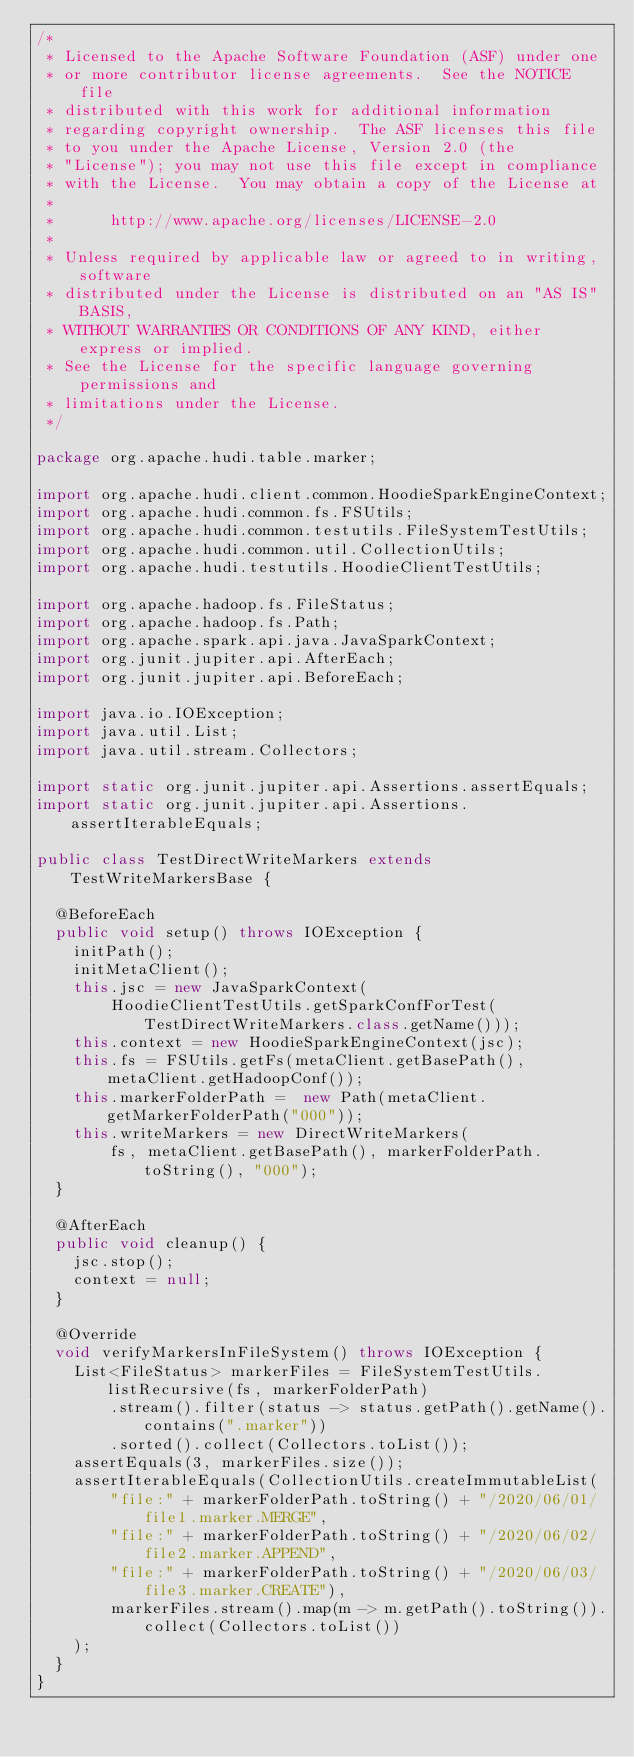<code> <loc_0><loc_0><loc_500><loc_500><_Java_>/*
 * Licensed to the Apache Software Foundation (ASF) under one
 * or more contributor license agreements.  See the NOTICE file
 * distributed with this work for additional information
 * regarding copyright ownership.  The ASF licenses this file
 * to you under the Apache License, Version 2.0 (the
 * "License"); you may not use this file except in compliance
 * with the License.  You may obtain a copy of the License at
 *
 *      http://www.apache.org/licenses/LICENSE-2.0
 *
 * Unless required by applicable law or agreed to in writing, software
 * distributed under the License is distributed on an "AS IS" BASIS,
 * WITHOUT WARRANTIES OR CONDITIONS OF ANY KIND, either express or implied.
 * See the License for the specific language governing permissions and
 * limitations under the License.
 */

package org.apache.hudi.table.marker;

import org.apache.hudi.client.common.HoodieSparkEngineContext;
import org.apache.hudi.common.fs.FSUtils;
import org.apache.hudi.common.testutils.FileSystemTestUtils;
import org.apache.hudi.common.util.CollectionUtils;
import org.apache.hudi.testutils.HoodieClientTestUtils;

import org.apache.hadoop.fs.FileStatus;
import org.apache.hadoop.fs.Path;
import org.apache.spark.api.java.JavaSparkContext;
import org.junit.jupiter.api.AfterEach;
import org.junit.jupiter.api.BeforeEach;

import java.io.IOException;
import java.util.List;
import java.util.stream.Collectors;

import static org.junit.jupiter.api.Assertions.assertEquals;
import static org.junit.jupiter.api.Assertions.assertIterableEquals;

public class TestDirectWriteMarkers extends TestWriteMarkersBase {

  @BeforeEach
  public void setup() throws IOException {
    initPath();
    initMetaClient();
    this.jsc = new JavaSparkContext(
        HoodieClientTestUtils.getSparkConfForTest(TestDirectWriteMarkers.class.getName()));
    this.context = new HoodieSparkEngineContext(jsc);
    this.fs = FSUtils.getFs(metaClient.getBasePath(), metaClient.getHadoopConf());
    this.markerFolderPath =  new Path(metaClient.getMarkerFolderPath("000"));
    this.writeMarkers = new DirectWriteMarkers(
        fs, metaClient.getBasePath(), markerFolderPath.toString(), "000");
  }

  @AfterEach
  public void cleanup() {
    jsc.stop();
    context = null;
  }

  @Override
  void verifyMarkersInFileSystem() throws IOException {
    List<FileStatus> markerFiles = FileSystemTestUtils.listRecursive(fs, markerFolderPath)
        .stream().filter(status -> status.getPath().getName().contains(".marker"))
        .sorted().collect(Collectors.toList());
    assertEquals(3, markerFiles.size());
    assertIterableEquals(CollectionUtils.createImmutableList(
        "file:" + markerFolderPath.toString() + "/2020/06/01/file1.marker.MERGE",
        "file:" + markerFolderPath.toString() + "/2020/06/02/file2.marker.APPEND",
        "file:" + markerFolderPath.toString() + "/2020/06/03/file3.marker.CREATE"),
        markerFiles.stream().map(m -> m.getPath().toString()).collect(Collectors.toList())
    );
  }
}
</code> 